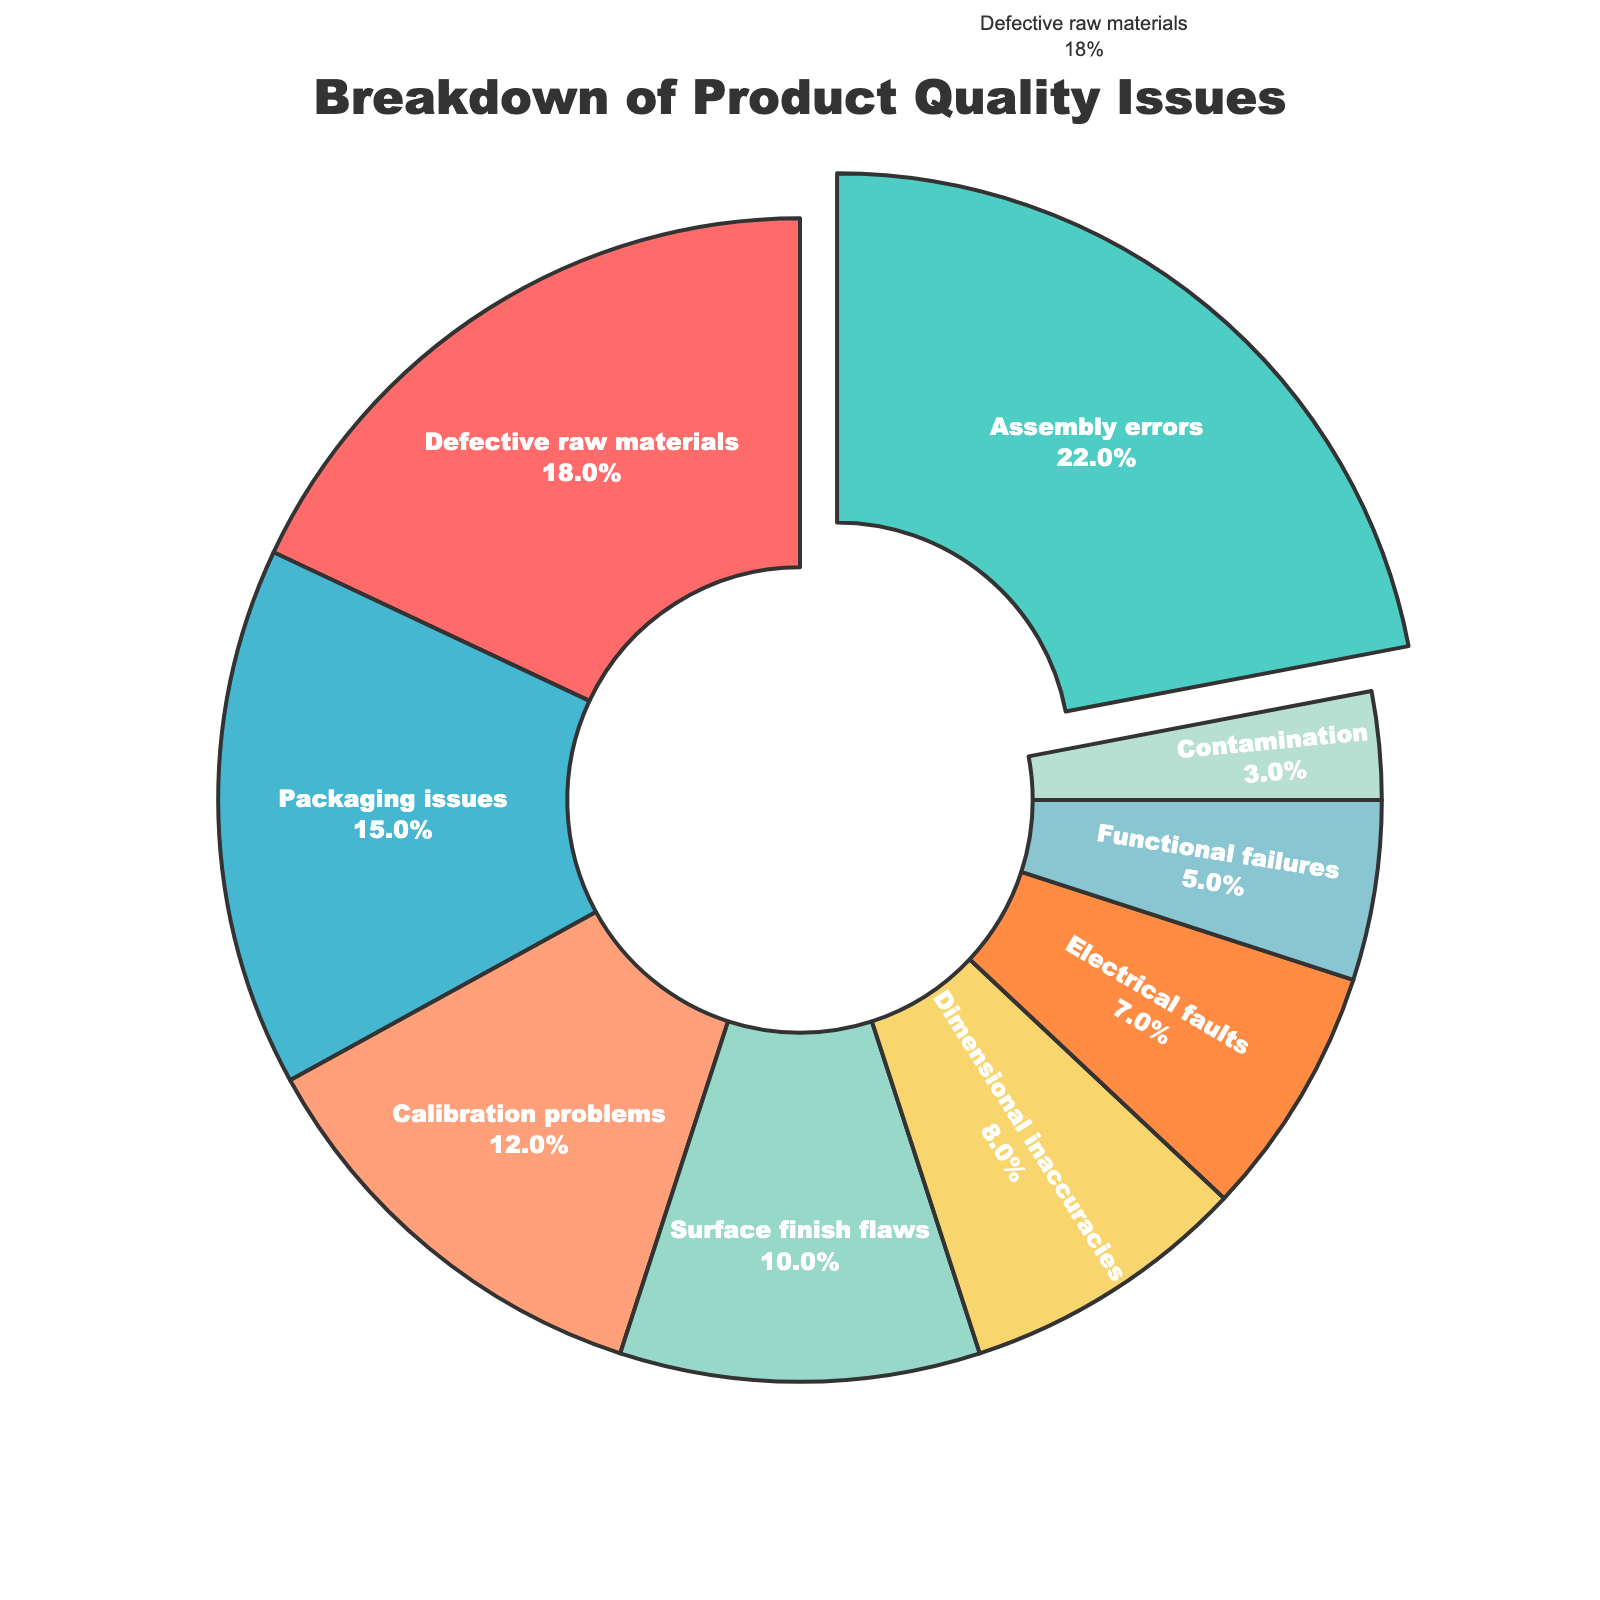Which category has the highest percentage of product quality issues? By looking at the chart, we can see that the segment labeled 'Assembly errors' is the largest.
Answer: Assembly errors Which two categories combined make up nearly 40% of the product quality issues? Adding the percentages of 'Assembly errors' (22%) and 'Defective raw materials' (18%) results in 40%.
Answer: Assembly errors and Defective raw materials How does the percentage of Packaging issues compare to that of Calibration problems? Packaging issues have 15% while Calibration problems have 12%. Therefore, Packaging issues have a higher percentage than Calibration problems.
Answer: Packaging issues are higher What is the cumulative percentage of the top three categories? Summing the top three categories: Assembly errors (22%), Defective raw materials (18%), and Packaging issues (15%) gives 55%.
Answer: 55% Which category has the smallest percentage of product quality issues, and what is that percentage? The chart shows that the smallest segment is 'Contamination' with 3%.
Answer: Contamination, 3% How much greater is the percentage of Surface finish flaws compared to Electrical faults? Subtracting Electrical faults (7%) from Surface finish flaws (10%) gives a difference of 3%.
Answer: 3% What percentage of product quality issues are related to Functional failures and Contamination combined? Adding Functional failures (5%) and Contamination (3%) gives 8%.
Answer: 8% How many categories have a percentage of product quality issues of 10% or higher? Identifying from the chart: Assembly errors (22%), Defective raw materials (18%), Packaging issues (15%), Calibration problems (12%), and Surface finish flaws (10%) sums up to 5 categories.
Answer: 5 If Assembly errors were reduced by 10%, which category would represent the highest percentage then? Reducing Assembly errors by 10% makes it 12%. The next highest category would be Defective raw materials with 18%.
Answer: Defective raw materials 